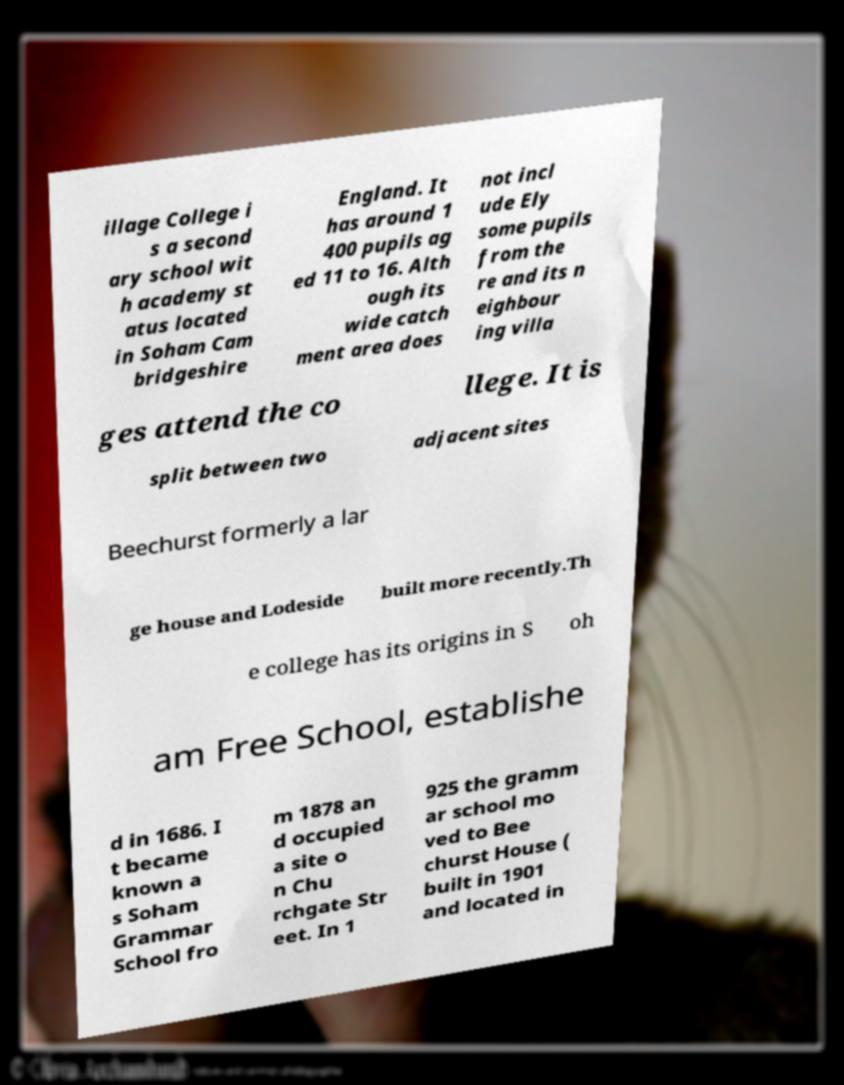Can you accurately transcribe the text from the provided image for me? illage College i s a second ary school wit h academy st atus located in Soham Cam bridgeshire England. It has around 1 400 pupils ag ed 11 to 16. Alth ough its wide catch ment area does not incl ude Ely some pupils from the re and its n eighbour ing villa ges attend the co llege. It is split between two adjacent sites Beechurst formerly a lar ge house and Lodeside built more recently.Th e college has its origins in S oh am Free School, establishe d in 1686. I t became known a s Soham Grammar School fro m 1878 an d occupied a site o n Chu rchgate Str eet. In 1 925 the gramm ar school mo ved to Bee churst House ( built in 1901 and located in 